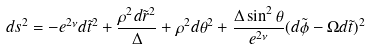<formula> <loc_0><loc_0><loc_500><loc_500>d s ^ { 2 } = - e ^ { 2 \nu } d \tilde { t } ^ { 2 } + \frac { \rho ^ { 2 } d \tilde { r } ^ { 2 } } { \Delta } + \rho ^ { 2 } d \theta ^ { 2 } + \frac { \Delta \sin ^ { 2 } { \theta } } { e ^ { 2 \nu } } ( d \tilde { \phi } - \Omega d \tilde { t } ) ^ { 2 }</formula> 